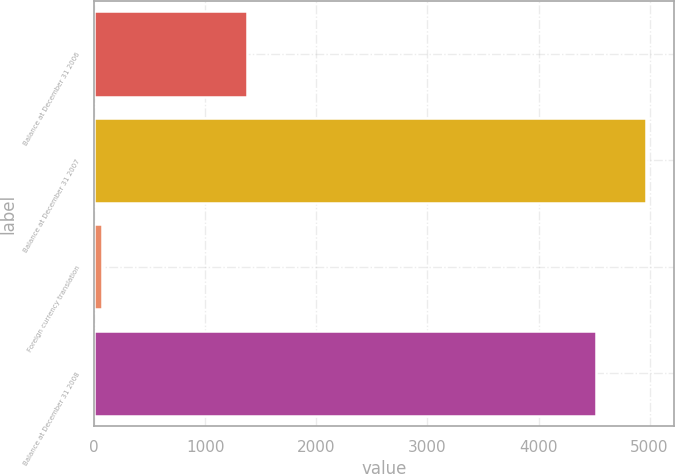Convert chart to OTSL. <chart><loc_0><loc_0><loc_500><loc_500><bar_chart><fcel>Balance at December 31 2006<fcel>Balance at December 31 2007<fcel>Foreign currency translation<fcel>Balance at December 31 2008<nl><fcel>1376<fcel>4970<fcel>69<fcel>4521<nl></chart> 